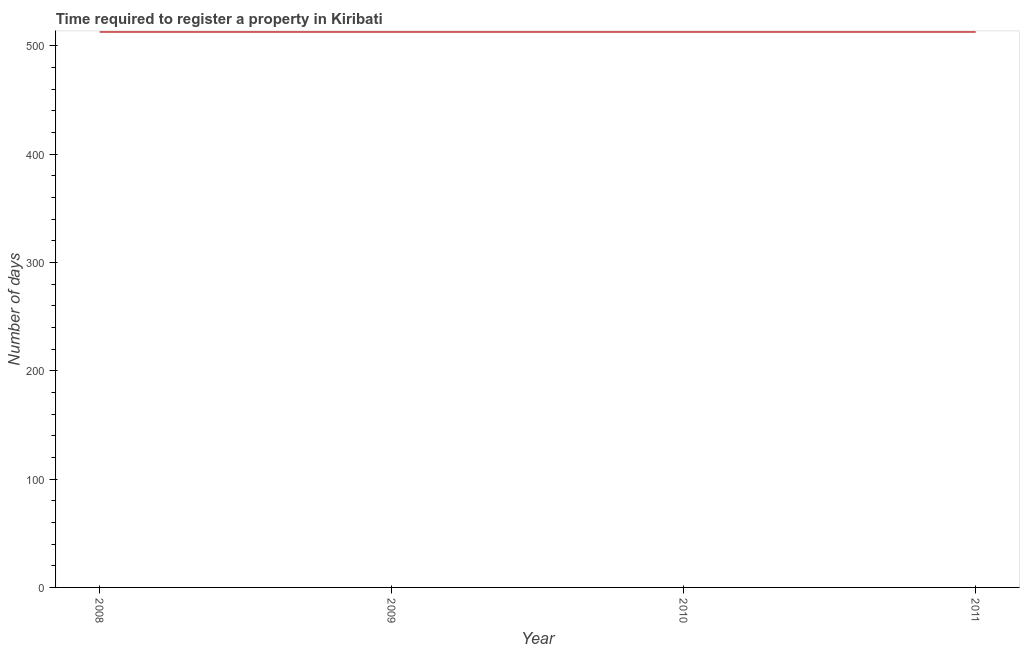What is the number of days required to register property in 2009?
Give a very brief answer. 513. Across all years, what is the maximum number of days required to register property?
Your answer should be very brief. 513. Across all years, what is the minimum number of days required to register property?
Your response must be concise. 513. In which year was the number of days required to register property minimum?
Your response must be concise. 2008. What is the sum of the number of days required to register property?
Offer a terse response. 2052. What is the difference between the number of days required to register property in 2009 and 2011?
Your answer should be very brief. 0. What is the average number of days required to register property per year?
Your response must be concise. 513. What is the median number of days required to register property?
Your answer should be compact. 513. What is the ratio of the number of days required to register property in 2008 to that in 2009?
Give a very brief answer. 1. Is the number of days required to register property in 2008 less than that in 2009?
Your answer should be compact. No. Is the difference between the number of days required to register property in 2008 and 2010 greater than the difference between any two years?
Provide a succinct answer. Yes. What is the difference between the highest and the second highest number of days required to register property?
Offer a very short reply. 0. Is the sum of the number of days required to register property in 2008 and 2011 greater than the maximum number of days required to register property across all years?
Your answer should be compact. Yes. Does the number of days required to register property monotonically increase over the years?
Ensure brevity in your answer.  No. How many lines are there?
Make the answer very short. 1. How many years are there in the graph?
Give a very brief answer. 4. What is the difference between two consecutive major ticks on the Y-axis?
Ensure brevity in your answer.  100. Does the graph contain any zero values?
Your response must be concise. No. What is the title of the graph?
Offer a terse response. Time required to register a property in Kiribati. What is the label or title of the X-axis?
Provide a succinct answer. Year. What is the label or title of the Y-axis?
Offer a very short reply. Number of days. What is the Number of days of 2008?
Offer a very short reply. 513. What is the Number of days of 2009?
Provide a short and direct response. 513. What is the Number of days of 2010?
Keep it short and to the point. 513. What is the Number of days in 2011?
Offer a terse response. 513. What is the difference between the Number of days in 2009 and 2011?
Your answer should be very brief. 0. What is the difference between the Number of days in 2010 and 2011?
Make the answer very short. 0. What is the ratio of the Number of days in 2008 to that in 2009?
Ensure brevity in your answer.  1. What is the ratio of the Number of days in 2008 to that in 2010?
Provide a succinct answer. 1. What is the ratio of the Number of days in 2008 to that in 2011?
Offer a very short reply. 1. What is the ratio of the Number of days in 2010 to that in 2011?
Offer a very short reply. 1. 